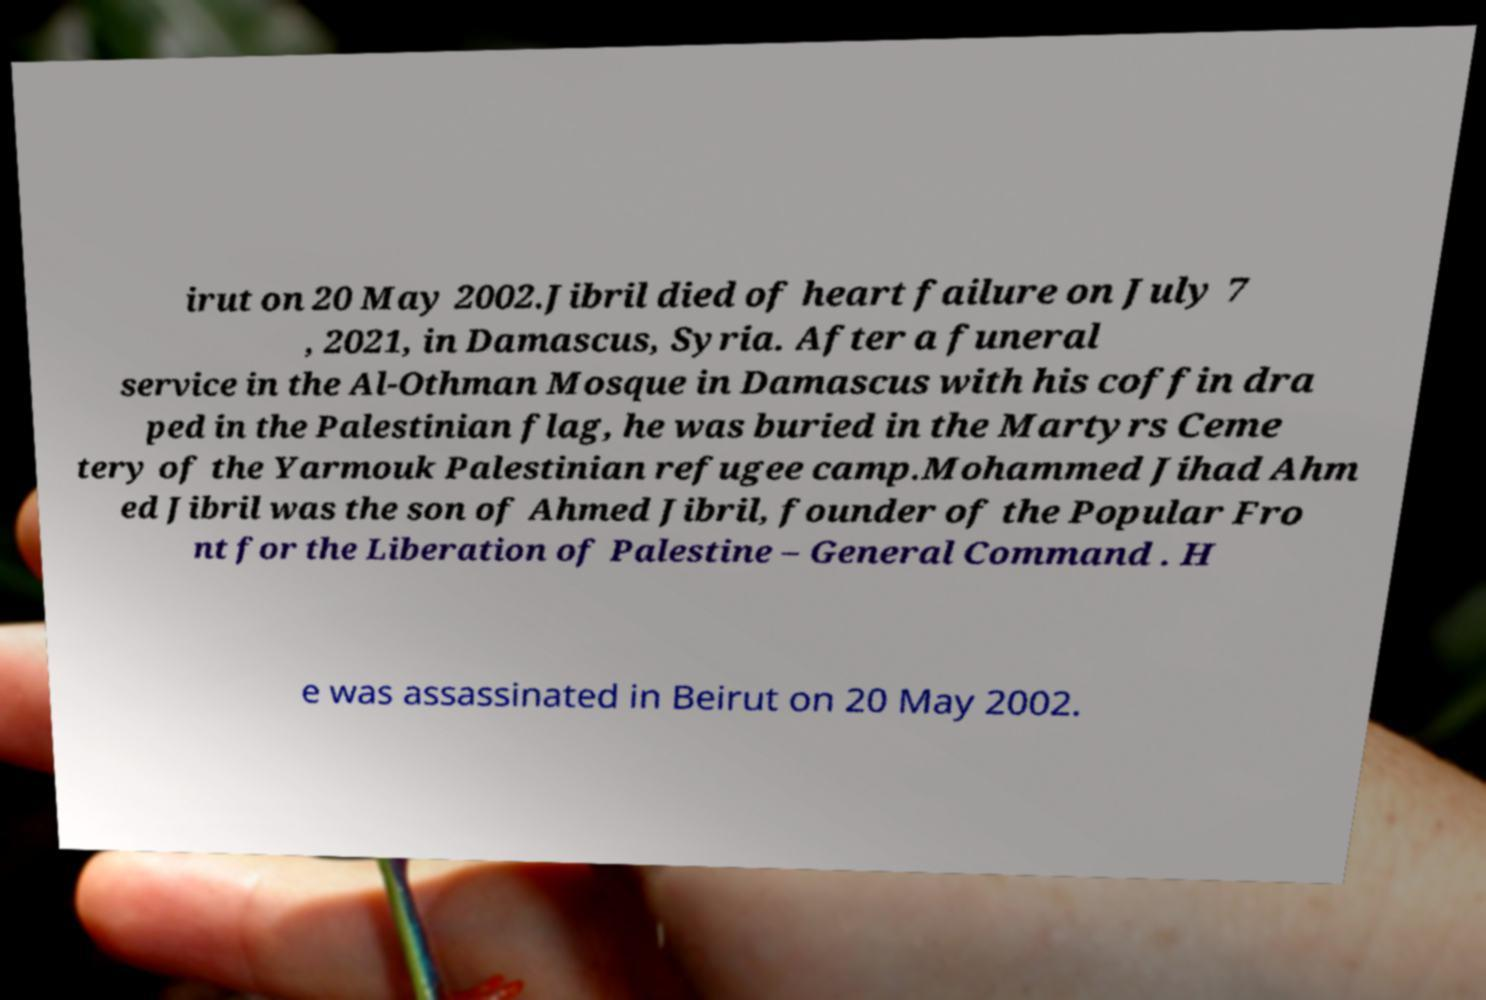There's text embedded in this image that I need extracted. Can you transcribe it verbatim? irut on 20 May 2002.Jibril died of heart failure on July 7 , 2021, in Damascus, Syria. After a funeral service in the Al-Othman Mosque in Damascus with his coffin dra ped in the Palestinian flag, he was buried in the Martyrs Ceme tery of the Yarmouk Palestinian refugee camp.Mohammed Jihad Ahm ed Jibril was the son of Ahmed Jibril, founder of the Popular Fro nt for the Liberation of Palestine – General Command . H e was assassinated in Beirut on 20 May 2002. 